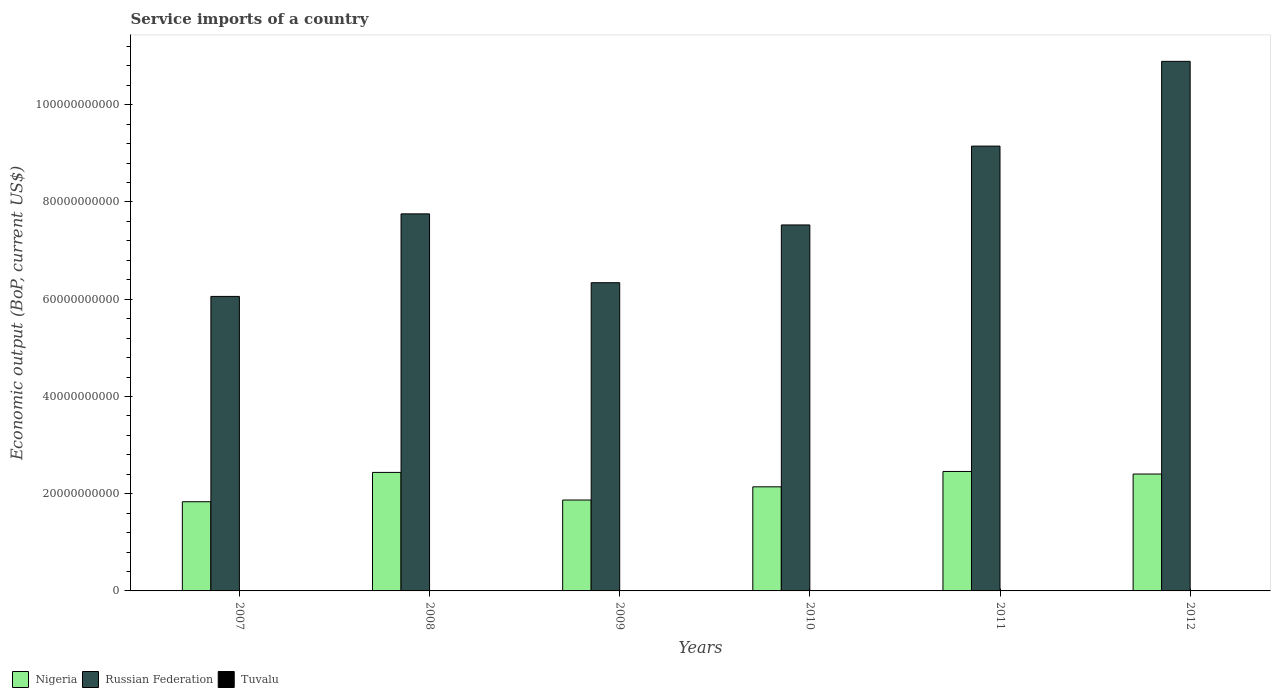How many different coloured bars are there?
Give a very brief answer. 3. Are the number of bars per tick equal to the number of legend labels?
Offer a very short reply. Yes. Are the number of bars on each tick of the X-axis equal?
Your response must be concise. Yes. How many bars are there on the 3rd tick from the left?
Offer a very short reply. 3. How many bars are there on the 6th tick from the right?
Your answer should be very brief. 3. What is the service imports in Tuvalu in 2012?
Your answer should be compact. 2.76e+07. Across all years, what is the maximum service imports in Nigeria?
Offer a very short reply. 2.46e+1. Across all years, what is the minimum service imports in Nigeria?
Provide a succinct answer. 1.83e+1. In which year was the service imports in Tuvalu maximum?
Make the answer very short. 2011. In which year was the service imports in Tuvalu minimum?
Your response must be concise. 2007. What is the total service imports in Tuvalu in the graph?
Provide a succinct answer. 1.84e+08. What is the difference between the service imports in Tuvalu in 2007 and that in 2009?
Ensure brevity in your answer.  -5.16e+06. What is the difference between the service imports in Tuvalu in 2011 and the service imports in Russian Federation in 2007?
Give a very brief answer. -6.05e+1. What is the average service imports in Russian Federation per year?
Provide a succinct answer. 7.95e+1. In the year 2012, what is the difference between the service imports in Russian Federation and service imports in Tuvalu?
Provide a short and direct response. 1.09e+11. In how many years, is the service imports in Nigeria greater than 92000000000 US$?
Your answer should be very brief. 0. What is the ratio of the service imports in Nigeria in 2009 to that in 2010?
Keep it short and to the point. 0.87. What is the difference between the highest and the second highest service imports in Tuvalu?
Give a very brief answer. 1.02e+07. What is the difference between the highest and the lowest service imports in Tuvalu?
Provide a short and direct response. 2.21e+07. Is the sum of the service imports in Tuvalu in 2008 and 2011 greater than the maximum service imports in Nigeria across all years?
Ensure brevity in your answer.  No. What does the 2nd bar from the left in 2008 represents?
Give a very brief answer. Russian Federation. What does the 2nd bar from the right in 2010 represents?
Offer a terse response. Russian Federation. Is it the case that in every year, the sum of the service imports in Nigeria and service imports in Tuvalu is greater than the service imports in Russian Federation?
Ensure brevity in your answer.  No. How many years are there in the graph?
Offer a terse response. 6. Does the graph contain any zero values?
Give a very brief answer. No. Does the graph contain grids?
Provide a short and direct response. No. What is the title of the graph?
Make the answer very short. Service imports of a country. Does "Northern Mariana Islands" appear as one of the legend labels in the graph?
Offer a very short reply. No. What is the label or title of the X-axis?
Your answer should be compact. Years. What is the label or title of the Y-axis?
Ensure brevity in your answer.  Economic output (BoP, current US$). What is the Economic output (BoP, current US$) of Nigeria in 2007?
Give a very brief answer. 1.83e+1. What is the Economic output (BoP, current US$) in Russian Federation in 2007?
Provide a succinct answer. 6.06e+1. What is the Economic output (BoP, current US$) in Tuvalu in 2007?
Give a very brief answer. 2.19e+07. What is the Economic output (BoP, current US$) in Nigeria in 2008?
Offer a very short reply. 2.44e+1. What is the Economic output (BoP, current US$) of Russian Federation in 2008?
Give a very brief answer. 7.76e+1. What is the Economic output (BoP, current US$) of Tuvalu in 2008?
Make the answer very short. 2.99e+07. What is the Economic output (BoP, current US$) of Nigeria in 2009?
Keep it short and to the point. 1.87e+1. What is the Economic output (BoP, current US$) of Russian Federation in 2009?
Give a very brief answer. 6.34e+1. What is the Economic output (BoP, current US$) in Tuvalu in 2009?
Ensure brevity in your answer.  2.70e+07. What is the Economic output (BoP, current US$) of Nigeria in 2010?
Give a very brief answer. 2.14e+1. What is the Economic output (BoP, current US$) in Russian Federation in 2010?
Your answer should be very brief. 7.53e+1. What is the Economic output (BoP, current US$) of Tuvalu in 2010?
Offer a very short reply. 3.38e+07. What is the Economic output (BoP, current US$) of Nigeria in 2011?
Give a very brief answer. 2.46e+1. What is the Economic output (BoP, current US$) in Russian Federation in 2011?
Give a very brief answer. 9.15e+1. What is the Economic output (BoP, current US$) of Tuvalu in 2011?
Provide a short and direct response. 4.40e+07. What is the Economic output (BoP, current US$) of Nigeria in 2012?
Give a very brief answer. 2.40e+1. What is the Economic output (BoP, current US$) of Russian Federation in 2012?
Make the answer very short. 1.09e+11. What is the Economic output (BoP, current US$) of Tuvalu in 2012?
Offer a terse response. 2.76e+07. Across all years, what is the maximum Economic output (BoP, current US$) of Nigeria?
Make the answer very short. 2.46e+1. Across all years, what is the maximum Economic output (BoP, current US$) in Russian Federation?
Provide a succinct answer. 1.09e+11. Across all years, what is the maximum Economic output (BoP, current US$) in Tuvalu?
Ensure brevity in your answer.  4.40e+07. Across all years, what is the minimum Economic output (BoP, current US$) of Nigeria?
Your answer should be compact. 1.83e+1. Across all years, what is the minimum Economic output (BoP, current US$) of Russian Federation?
Provide a succinct answer. 6.06e+1. Across all years, what is the minimum Economic output (BoP, current US$) in Tuvalu?
Provide a short and direct response. 2.19e+07. What is the total Economic output (BoP, current US$) of Nigeria in the graph?
Your response must be concise. 1.31e+11. What is the total Economic output (BoP, current US$) of Russian Federation in the graph?
Keep it short and to the point. 4.77e+11. What is the total Economic output (BoP, current US$) of Tuvalu in the graph?
Your answer should be very brief. 1.84e+08. What is the difference between the Economic output (BoP, current US$) in Nigeria in 2007 and that in 2008?
Your response must be concise. -6.03e+09. What is the difference between the Economic output (BoP, current US$) in Russian Federation in 2007 and that in 2008?
Make the answer very short. -1.70e+1. What is the difference between the Economic output (BoP, current US$) of Tuvalu in 2007 and that in 2008?
Keep it short and to the point. -8.02e+06. What is the difference between the Economic output (BoP, current US$) of Nigeria in 2007 and that in 2009?
Your response must be concise. -3.52e+08. What is the difference between the Economic output (BoP, current US$) in Russian Federation in 2007 and that in 2009?
Keep it short and to the point. -2.82e+09. What is the difference between the Economic output (BoP, current US$) of Tuvalu in 2007 and that in 2009?
Provide a succinct answer. -5.16e+06. What is the difference between the Economic output (BoP, current US$) of Nigeria in 2007 and that in 2010?
Keep it short and to the point. -3.07e+09. What is the difference between the Economic output (BoP, current US$) in Russian Federation in 2007 and that in 2010?
Provide a short and direct response. -1.47e+1. What is the difference between the Economic output (BoP, current US$) in Tuvalu in 2007 and that in 2010?
Keep it short and to the point. -1.20e+07. What is the difference between the Economic output (BoP, current US$) in Nigeria in 2007 and that in 2011?
Your answer should be compact. -6.23e+09. What is the difference between the Economic output (BoP, current US$) of Russian Federation in 2007 and that in 2011?
Ensure brevity in your answer.  -3.09e+1. What is the difference between the Economic output (BoP, current US$) of Tuvalu in 2007 and that in 2011?
Give a very brief answer. -2.21e+07. What is the difference between the Economic output (BoP, current US$) of Nigeria in 2007 and that in 2012?
Provide a succinct answer. -5.70e+09. What is the difference between the Economic output (BoP, current US$) of Russian Federation in 2007 and that in 2012?
Ensure brevity in your answer.  -4.83e+1. What is the difference between the Economic output (BoP, current US$) of Tuvalu in 2007 and that in 2012?
Your response must be concise. -5.70e+06. What is the difference between the Economic output (BoP, current US$) in Nigeria in 2008 and that in 2009?
Keep it short and to the point. 5.68e+09. What is the difference between the Economic output (BoP, current US$) in Russian Federation in 2008 and that in 2009?
Offer a terse response. 1.42e+1. What is the difference between the Economic output (BoP, current US$) of Tuvalu in 2008 and that in 2009?
Keep it short and to the point. 2.86e+06. What is the difference between the Economic output (BoP, current US$) in Nigeria in 2008 and that in 2010?
Give a very brief answer. 2.97e+09. What is the difference between the Economic output (BoP, current US$) in Russian Federation in 2008 and that in 2010?
Provide a succinct answer. 2.28e+09. What is the difference between the Economic output (BoP, current US$) of Tuvalu in 2008 and that in 2010?
Provide a short and direct response. -3.95e+06. What is the difference between the Economic output (BoP, current US$) of Nigeria in 2008 and that in 2011?
Offer a very short reply. -1.97e+08. What is the difference between the Economic output (BoP, current US$) of Russian Federation in 2008 and that in 2011?
Your response must be concise. -1.39e+1. What is the difference between the Economic output (BoP, current US$) in Tuvalu in 2008 and that in 2011?
Offer a terse response. -1.41e+07. What is the difference between the Economic output (BoP, current US$) in Nigeria in 2008 and that in 2012?
Offer a very short reply. 3.32e+08. What is the difference between the Economic output (BoP, current US$) in Russian Federation in 2008 and that in 2012?
Offer a terse response. -3.14e+1. What is the difference between the Economic output (BoP, current US$) of Tuvalu in 2008 and that in 2012?
Your response must be concise. 2.32e+06. What is the difference between the Economic output (BoP, current US$) in Nigeria in 2009 and that in 2010?
Your answer should be compact. -2.71e+09. What is the difference between the Economic output (BoP, current US$) in Russian Federation in 2009 and that in 2010?
Keep it short and to the point. -1.19e+1. What is the difference between the Economic output (BoP, current US$) of Tuvalu in 2009 and that in 2010?
Make the answer very short. -6.81e+06. What is the difference between the Economic output (BoP, current US$) in Nigeria in 2009 and that in 2011?
Your answer should be compact. -5.88e+09. What is the difference between the Economic output (BoP, current US$) of Russian Federation in 2009 and that in 2011?
Keep it short and to the point. -2.81e+1. What is the difference between the Economic output (BoP, current US$) of Tuvalu in 2009 and that in 2011?
Give a very brief answer. -1.70e+07. What is the difference between the Economic output (BoP, current US$) in Nigeria in 2009 and that in 2012?
Your response must be concise. -5.35e+09. What is the difference between the Economic output (BoP, current US$) of Russian Federation in 2009 and that in 2012?
Your response must be concise. -4.55e+1. What is the difference between the Economic output (BoP, current US$) of Tuvalu in 2009 and that in 2012?
Offer a terse response. -5.33e+05. What is the difference between the Economic output (BoP, current US$) in Nigeria in 2010 and that in 2011?
Your answer should be compact. -3.16e+09. What is the difference between the Economic output (BoP, current US$) in Russian Federation in 2010 and that in 2011?
Give a very brief answer. -1.62e+1. What is the difference between the Economic output (BoP, current US$) in Tuvalu in 2010 and that in 2011?
Your answer should be compact. -1.02e+07. What is the difference between the Economic output (BoP, current US$) in Nigeria in 2010 and that in 2012?
Your answer should be compact. -2.63e+09. What is the difference between the Economic output (BoP, current US$) in Russian Federation in 2010 and that in 2012?
Offer a terse response. -3.36e+1. What is the difference between the Economic output (BoP, current US$) in Tuvalu in 2010 and that in 2012?
Offer a terse response. 6.28e+06. What is the difference between the Economic output (BoP, current US$) in Nigeria in 2011 and that in 2012?
Make the answer very short. 5.29e+08. What is the difference between the Economic output (BoP, current US$) of Russian Federation in 2011 and that in 2012?
Offer a very short reply. -1.74e+1. What is the difference between the Economic output (BoP, current US$) in Tuvalu in 2011 and that in 2012?
Offer a very short reply. 1.64e+07. What is the difference between the Economic output (BoP, current US$) of Nigeria in 2007 and the Economic output (BoP, current US$) of Russian Federation in 2008?
Make the answer very short. -5.92e+1. What is the difference between the Economic output (BoP, current US$) in Nigeria in 2007 and the Economic output (BoP, current US$) in Tuvalu in 2008?
Make the answer very short. 1.83e+1. What is the difference between the Economic output (BoP, current US$) of Russian Federation in 2007 and the Economic output (BoP, current US$) of Tuvalu in 2008?
Your answer should be compact. 6.05e+1. What is the difference between the Economic output (BoP, current US$) in Nigeria in 2007 and the Economic output (BoP, current US$) in Russian Federation in 2009?
Provide a succinct answer. -4.51e+1. What is the difference between the Economic output (BoP, current US$) in Nigeria in 2007 and the Economic output (BoP, current US$) in Tuvalu in 2009?
Your response must be concise. 1.83e+1. What is the difference between the Economic output (BoP, current US$) in Russian Federation in 2007 and the Economic output (BoP, current US$) in Tuvalu in 2009?
Your answer should be very brief. 6.06e+1. What is the difference between the Economic output (BoP, current US$) of Nigeria in 2007 and the Economic output (BoP, current US$) of Russian Federation in 2010?
Your answer should be compact. -5.69e+1. What is the difference between the Economic output (BoP, current US$) of Nigeria in 2007 and the Economic output (BoP, current US$) of Tuvalu in 2010?
Your answer should be very brief. 1.83e+1. What is the difference between the Economic output (BoP, current US$) of Russian Federation in 2007 and the Economic output (BoP, current US$) of Tuvalu in 2010?
Provide a short and direct response. 6.05e+1. What is the difference between the Economic output (BoP, current US$) of Nigeria in 2007 and the Economic output (BoP, current US$) of Russian Federation in 2011?
Your answer should be compact. -7.32e+1. What is the difference between the Economic output (BoP, current US$) of Nigeria in 2007 and the Economic output (BoP, current US$) of Tuvalu in 2011?
Your response must be concise. 1.83e+1. What is the difference between the Economic output (BoP, current US$) in Russian Federation in 2007 and the Economic output (BoP, current US$) in Tuvalu in 2011?
Offer a terse response. 6.05e+1. What is the difference between the Economic output (BoP, current US$) of Nigeria in 2007 and the Economic output (BoP, current US$) of Russian Federation in 2012?
Give a very brief answer. -9.06e+1. What is the difference between the Economic output (BoP, current US$) of Nigeria in 2007 and the Economic output (BoP, current US$) of Tuvalu in 2012?
Your response must be concise. 1.83e+1. What is the difference between the Economic output (BoP, current US$) in Russian Federation in 2007 and the Economic output (BoP, current US$) in Tuvalu in 2012?
Ensure brevity in your answer.  6.06e+1. What is the difference between the Economic output (BoP, current US$) of Nigeria in 2008 and the Economic output (BoP, current US$) of Russian Federation in 2009?
Give a very brief answer. -3.90e+1. What is the difference between the Economic output (BoP, current US$) of Nigeria in 2008 and the Economic output (BoP, current US$) of Tuvalu in 2009?
Keep it short and to the point. 2.43e+1. What is the difference between the Economic output (BoP, current US$) of Russian Federation in 2008 and the Economic output (BoP, current US$) of Tuvalu in 2009?
Make the answer very short. 7.75e+1. What is the difference between the Economic output (BoP, current US$) of Nigeria in 2008 and the Economic output (BoP, current US$) of Russian Federation in 2010?
Your response must be concise. -5.09e+1. What is the difference between the Economic output (BoP, current US$) in Nigeria in 2008 and the Economic output (BoP, current US$) in Tuvalu in 2010?
Offer a terse response. 2.43e+1. What is the difference between the Economic output (BoP, current US$) in Russian Federation in 2008 and the Economic output (BoP, current US$) in Tuvalu in 2010?
Offer a terse response. 7.75e+1. What is the difference between the Economic output (BoP, current US$) of Nigeria in 2008 and the Economic output (BoP, current US$) of Russian Federation in 2011?
Your answer should be compact. -6.71e+1. What is the difference between the Economic output (BoP, current US$) of Nigeria in 2008 and the Economic output (BoP, current US$) of Tuvalu in 2011?
Make the answer very short. 2.43e+1. What is the difference between the Economic output (BoP, current US$) in Russian Federation in 2008 and the Economic output (BoP, current US$) in Tuvalu in 2011?
Your answer should be compact. 7.75e+1. What is the difference between the Economic output (BoP, current US$) of Nigeria in 2008 and the Economic output (BoP, current US$) of Russian Federation in 2012?
Offer a terse response. -8.46e+1. What is the difference between the Economic output (BoP, current US$) of Nigeria in 2008 and the Economic output (BoP, current US$) of Tuvalu in 2012?
Keep it short and to the point. 2.43e+1. What is the difference between the Economic output (BoP, current US$) in Russian Federation in 2008 and the Economic output (BoP, current US$) in Tuvalu in 2012?
Give a very brief answer. 7.75e+1. What is the difference between the Economic output (BoP, current US$) in Nigeria in 2009 and the Economic output (BoP, current US$) in Russian Federation in 2010?
Provide a succinct answer. -5.66e+1. What is the difference between the Economic output (BoP, current US$) in Nigeria in 2009 and the Economic output (BoP, current US$) in Tuvalu in 2010?
Your response must be concise. 1.87e+1. What is the difference between the Economic output (BoP, current US$) of Russian Federation in 2009 and the Economic output (BoP, current US$) of Tuvalu in 2010?
Offer a terse response. 6.34e+1. What is the difference between the Economic output (BoP, current US$) of Nigeria in 2009 and the Economic output (BoP, current US$) of Russian Federation in 2011?
Provide a succinct answer. -7.28e+1. What is the difference between the Economic output (BoP, current US$) of Nigeria in 2009 and the Economic output (BoP, current US$) of Tuvalu in 2011?
Offer a terse response. 1.87e+1. What is the difference between the Economic output (BoP, current US$) in Russian Federation in 2009 and the Economic output (BoP, current US$) in Tuvalu in 2011?
Keep it short and to the point. 6.34e+1. What is the difference between the Economic output (BoP, current US$) of Nigeria in 2009 and the Economic output (BoP, current US$) of Russian Federation in 2012?
Keep it short and to the point. -9.02e+1. What is the difference between the Economic output (BoP, current US$) in Nigeria in 2009 and the Economic output (BoP, current US$) in Tuvalu in 2012?
Give a very brief answer. 1.87e+1. What is the difference between the Economic output (BoP, current US$) in Russian Federation in 2009 and the Economic output (BoP, current US$) in Tuvalu in 2012?
Offer a terse response. 6.34e+1. What is the difference between the Economic output (BoP, current US$) of Nigeria in 2010 and the Economic output (BoP, current US$) of Russian Federation in 2011?
Your response must be concise. -7.01e+1. What is the difference between the Economic output (BoP, current US$) in Nigeria in 2010 and the Economic output (BoP, current US$) in Tuvalu in 2011?
Your answer should be very brief. 2.14e+1. What is the difference between the Economic output (BoP, current US$) of Russian Federation in 2010 and the Economic output (BoP, current US$) of Tuvalu in 2011?
Provide a succinct answer. 7.52e+1. What is the difference between the Economic output (BoP, current US$) in Nigeria in 2010 and the Economic output (BoP, current US$) in Russian Federation in 2012?
Ensure brevity in your answer.  -8.75e+1. What is the difference between the Economic output (BoP, current US$) of Nigeria in 2010 and the Economic output (BoP, current US$) of Tuvalu in 2012?
Make the answer very short. 2.14e+1. What is the difference between the Economic output (BoP, current US$) in Russian Federation in 2010 and the Economic output (BoP, current US$) in Tuvalu in 2012?
Make the answer very short. 7.53e+1. What is the difference between the Economic output (BoP, current US$) in Nigeria in 2011 and the Economic output (BoP, current US$) in Russian Federation in 2012?
Your answer should be compact. -8.44e+1. What is the difference between the Economic output (BoP, current US$) of Nigeria in 2011 and the Economic output (BoP, current US$) of Tuvalu in 2012?
Give a very brief answer. 2.45e+1. What is the difference between the Economic output (BoP, current US$) in Russian Federation in 2011 and the Economic output (BoP, current US$) in Tuvalu in 2012?
Keep it short and to the point. 9.15e+1. What is the average Economic output (BoP, current US$) of Nigeria per year?
Provide a succinct answer. 2.19e+1. What is the average Economic output (BoP, current US$) in Russian Federation per year?
Provide a succinct answer. 7.95e+1. What is the average Economic output (BoP, current US$) in Tuvalu per year?
Your answer should be compact. 3.07e+07. In the year 2007, what is the difference between the Economic output (BoP, current US$) of Nigeria and Economic output (BoP, current US$) of Russian Federation?
Your answer should be compact. -4.22e+1. In the year 2007, what is the difference between the Economic output (BoP, current US$) in Nigeria and Economic output (BoP, current US$) in Tuvalu?
Offer a terse response. 1.83e+1. In the year 2007, what is the difference between the Economic output (BoP, current US$) in Russian Federation and Economic output (BoP, current US$) in Tuvalu?
Give a very brief answer. 6.06e+1. In the year 2008, what is the difference between the Economic output (BoP, current US$) in Nigeria and Economic output (BoP, current US$) in Russian Federation?
Offer a very short reply. -5.32e+1. In the year 2008, what is the difference between the Economic output (BoP, current US$) of Nigeria and Economic output (BoP, current US$) of Tuvalu?
Give a very brief answer. 2.43e+1. In the year 2008, what is the difference between the Economic output (BoP, current US$) of Russian Federation and Economic output (BoP, current US$) of Tuvalu?
Offer a very short reply. 7.75e+1. In the year 2009, what is the difference between the Economic output (BoP, current US$) of Nigeria and Economic output (BoP, current US$) of Russian Federation?
Ensure brevity in your answer.  -4.47e+1. In the year 2009, what is the difference between the Economic output (BoP, current US$) of Nigeria and Economic output (BoP, current US$) of Tuvalu?
Your answer should be compact. 1.87e+1. In the year 2009, what is the difference between the Economic output (BoP, current US$) in Russian Federation and Economic output (BoP, current US$) in Tuvalu?
Provide a short and direct response. 6.34e+1. In the year 2010, what is the difference between the Economic output (BoP, current US$) of Nigeria and Economic output (BoP, current US$) of Russian Federation?
Your answer should be very brief. -5.39e+1. In the year 2010, what is the difference between the Economic output (BoP, current US$) of Nigeria and Economic output (BoP, current US$) of Tuvalu?
Ensure brevity in your answer.  2.14e+1. In the year 2010, what is the difference between the Economic output (BoP, current US$) of Russian Federation and Economic output (BoP, current US$) of Tuvalu?
Your answer should be compact. 7.52e+1. In the year 2011, what is the difference between the Economic output (BoP, current US$) in Nigeria and Economic output (BoP, current US$) in Russian Federation?
Make the answer very short. -6.69e+1. In the year 2011, what is the difference between the Economic output (BoP, current US$) of Nigeria and Economic output (BoP, current US$) of Tuvalu?
Offer a very short reply. 2.45e+1. In the year 2011, what is the difference between the Economic output (BoP, current US$) in Russian Federation and Economic output (BoP, current US$) in Tuvalu?
Make the answer very short. 9.15e+1. In the year 2012, what is the difference between the Economic output (BoP, current US$) in Nigeria and Economic output (BoP, current US$) in Russian Federation?
Keep it short and to the point. -8.49e+1. In the year 2012, what is the difference between the Economic output (BoP, current US$) in Nigeria and Economic output (BoP, current US$) in Tuvalu?
Provide a short and direct response. 2.40e+1. In the year 2012, what is the difference between the Economic output (BoP, current US$) of Russian Federation and Economic output (BoP, current US$) of Tuvalu?
Offer a very short reply. 1.09e+11. What is the ratio of the Economic output (BoP, current US$) of Nigeria in 2007 to that in 2008?
Make the answer very short. 0.75. What is the ratio of the Economic output (BoP, current US$) of Russian Federation in 2007 to that in 2008?
Your answer should be very brief. 0.78. What is the ratio of the Economic output (BoP, current US$) of Tuvalu in 2007 to that in 2008?
Offer a terse response. 0.73. What is the ratio of the Economic output (BoP, current US$) in Nigeria in 2007 to that in 2009?
Offer a very short reply. 0.98. What is the ratio of the Economic output (BoP, current US$) in Russian Federation in 2007 to that in 2009?
Keep it short and to the point. 0.96. What is the ratio of the Economic output (BoP, current US$) of Tuvalu in 2007 to that in 2009?
Provide a short and direct response. 0.81. What is the ratio of the Economic output (BoP, current US$) in Nigeria in 2007 to that in 2010?
Your answer should be very brief. 0.86. What is the ratio of the Economic output (BoP, current US$) of Russian Federation in 2007 to that in 2010?
Your answer should be very brief. 0.8. What is the ratio of the Economic output (BoP, current US$) of Tuvalu in 2007 to that in 2010?
Make the answer very short. 0.65. What is the ratio of the Economic output (BoP, current US$) of Nigeria in 2007 to that in 2011?
Your response must be concise. 0.75. What is the ratio of the Economic output (BoP, current US$) of Russian Federation in 2007 to that in 2011?
Ensure brevity in your answer.  0.66. What is the ratio of the Economic output (BoP, current US$) in Tuvalu in 2007 to that in 2011?
Offer a terse response. 0.5. What is the ratio of the Economic output (BoP, current US$) in Nigeria in 2007 to that in 2012?
Give a very brief answer. 0.76. What is the ratio of the Economic output (BoP, current US$) of Russian Federation in 2007 to that in 2012?
Offer a terse response. 0.56. What is the ratio of the Economic output (BoP, current US$) in Tuvalu in 2007 to that in 2012?
Ensure brevity in your answer.  0.79. What is the ratio of the Economic output (BoP, current US$) in Nigeria in 2008 to that in 2009?
Provide a short and direct response. 1.3. What is the ratio of the Economic output (BoP, current US$) in Russian Federation in 2008 to that in 2009?
Keep it short and to the point. 1.22. What is the ratio of the Economic output (BoP, current US$) of Tuvalu in 2008 to that in 2009?
Offer a very short reply. 1.11. What is the ratio of the Economic output (BoP, current US$) of Nigeria in 2008 to that in 2010?
Your response must be concise. 1.14. What is the ratio of the Economic output (BoP, current US$) of Russian Federation in 2008 to that in 2010?
Make the answer very short. 1.03. What is the ratio of the Economic output (BoP, current US$) of Tuvalu in 2008 to that in 2010?
Your answer should be very brief. 0.88. What is the ratio of the Economic output (BoP, current US$) in Nigeria in 2008 to that in 2011?
Make the answer very short. 0.99. What is the ratio of the Economic output (BoP, current US$) of Russian Federation in 2008 to that in 2011?
Your answer should be compact. 0.85. What is the ratio of the Economic output (BoP, current US$) of Tuvalu in 2008 to that in 2011?
Offer a very short reply. 0.68. What is the ratio of the Economic output (BoP, current US$) in Nigeria in 2008 to that in 2012?
Your response must be concise. 1.01. What is the ratio of the Economic output (BoP, current US$) of Russian Federation in 2008 to that in 2012?
Make the answer very short. 0.71. What is the ratio of the Economic output (BoP, current US$) of Tuvalu in 2008 to that in 2012?
Provide a short and direct response. 1.08. What is the ratio of the Economic output (BoP, current US$) in Nigeria in 2009 to that in 2010?
Provide a short and direct response. 0.87. What is the ratio of the Economic output (BoP, current US$) in Russian Federation in 2009 to that in 2010?
Offer a very short reply. 0.84. What is the ratio of the Economic output (BoP, current US$) of Tuvalu in 2009 to that in 2010?
Give a very brief answer. 0.8. What is the ratio of the Economic output (BoP, current US$) in Nigeria in 2009 to that in 2011?
Your response must be concise. 0.76. What is the ratio of the Economic output (BoP, current US$) of Russian Federation in 2009 to that in 2011?
Ensure brevity in your answer.  0.69. What is the ratio of the Economic output (BoP, current US$) in Tuvalu in 2009 to that in 2011?
Keep it short and to the point. 0.61. What is the ratio of the Economic output (BoP, current US$) of Nigeria in 2009 to that in 2012?
Offer a terse response. 0.78. What is the ratio of the Economic output (BoP, current US$) in Russian Federation in 2009 to that in 2012?
Your response must be concise. 0.58. What is the ratio of the Economic output (BoP, current US$) in Tuvalu in 2009 to that in 2012?
Give a very brief answer. 0.98. What is the ratio of the Economic output (BoP, current US$) of Nigeria in 2010 to that in 2011?
Keep it short and to the point. 0.87. What is the ratio of the Economic output (BoP, current US$) in Russian Federation in 2010 to that in 2011?
Offer a very short reply. 0.82. What is the ratio of the Economic output (BoP, current US$) of Tuvalu in 2010 to that in 2011?
Your response must be concise. 0.77. What is the ratio of the Economic output (BoP, current US$) of Nigeria in 2010 to that in 2012?
Make the answer very short. 0.89. What is the ratio of the Economic output (BoP, current US$) in Russian Federation in 2010 to that in 2012?
Make the answer very short. 0.69. What is the ratio of the Economic output (BoP, current US$) of Tuvalu in 2010 to that in 2012?
Offer a very short reply. 1.23. What is the ratio of the Economic output (BoP, current US$) of Nigeria in 2011 to that in 2012?
Ensure brevity in your answer.  1.02. What is the ratio of the Economic output (BoP, current US$) in Russian Federation in 2011 to that in 2012?
Offer a very short reply. 0.84. What is the ratio of the Economic output (BoP, current US$) in Tuvalu in 2011 to that in 2012?
Provide a succinct answer. 1.6. What is the difference between the highest and the second highest Economic output (BoP, current US$) in Nigeria?
Make the answer very short. 1.97e+08. What is the difference between the highest and the second highest Economic output (BoP, current US$) of Russian Federation?
Make the answer very short. 1.74e+1. What is the difference between the highest and the second highest Economic output (BoP, current US$) of Tuvalu?
Offer a very short reply. 1.02e+07. What is the difference between the highest and the lowest Economic output (BoP, current US$) of Nigeria?
Offer a terse response. 6.23e+09. What is the difference between the highest and the lowest Economic output (BoP, current US$) in Russian Federation?
Keep it short and to the point. 4.83e+1. What is the difference between the highest and the lowest Economic output (BoP, current US$) of Tuvalu?
Ensure brevity in your answer.  2.21e+07. 